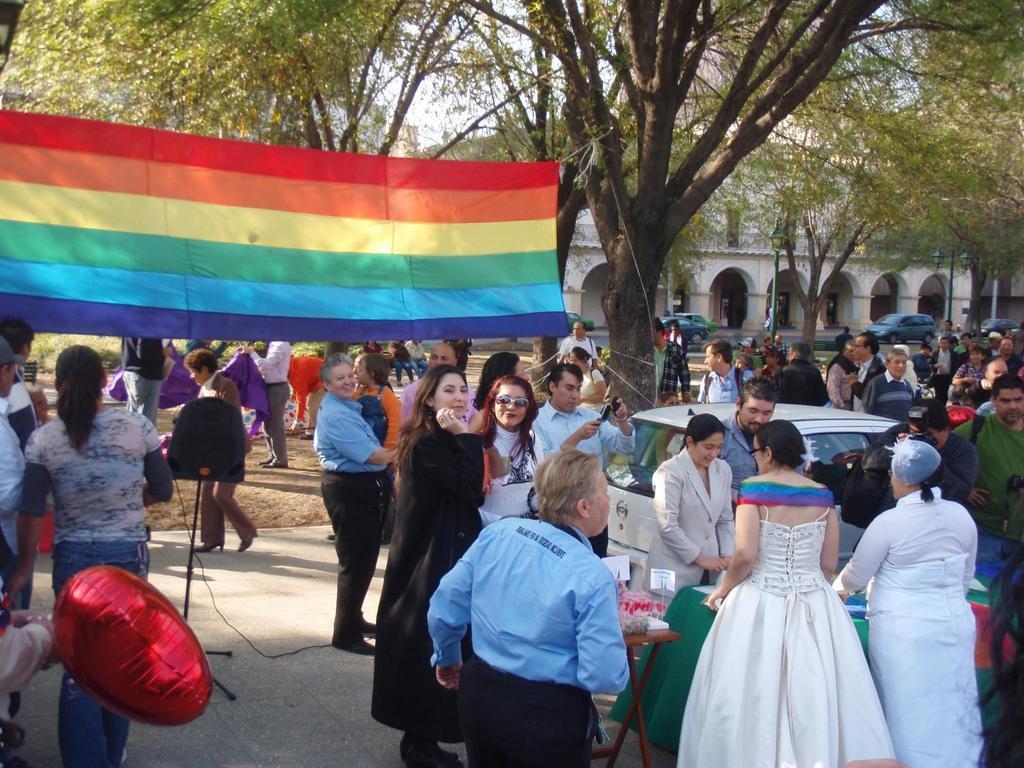Can you describe this image briefly? In this image I can see group of people are standing on the ground. Here I can see a car, tables which has some objects and a cloth which is in different colors. In the background I can see trees, a building and the sky. 